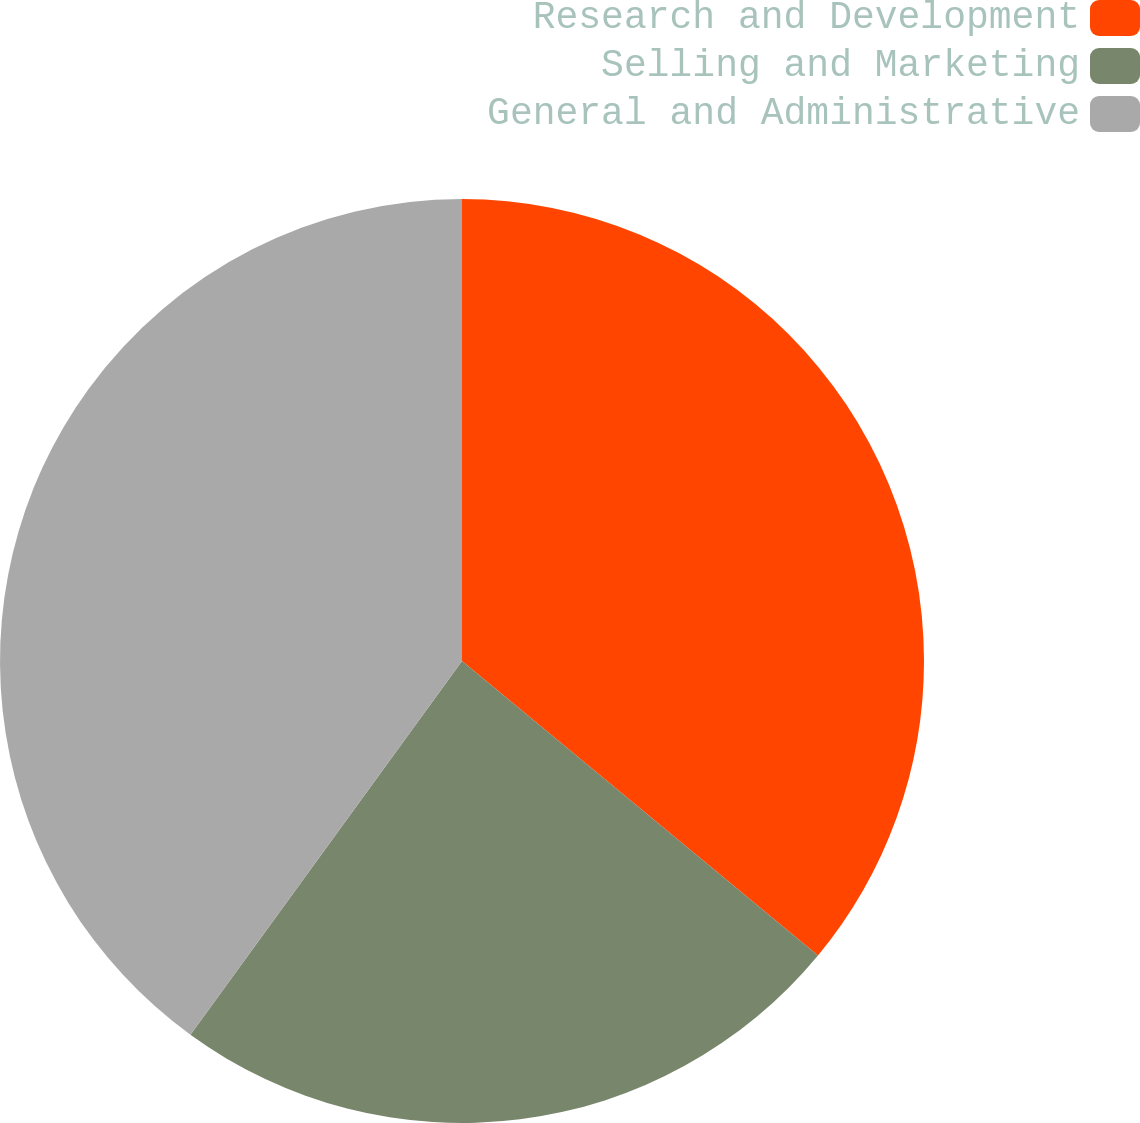<chart> <loc_0><loc_0><loc_500><loc_500><pie_chart><fcel>Research and Development<fcel>Selling and Marketing<fcel>General and Administrative<nl><fcel>36.0%<fcel>24.0%<fcel>40.0%<nl></chart> 